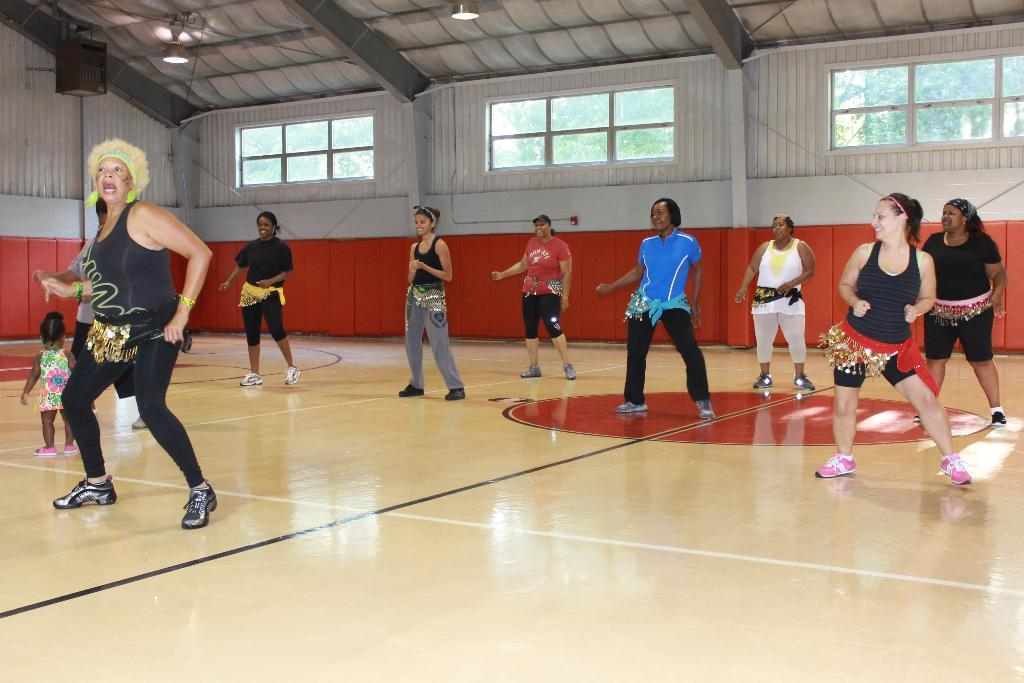How many people are in the image? There is a group of people in the image. Where are the people located in the image? The people are on the floor, near walls, windows, lights, and the roof. What can be seen in the background of the image? There are trees in the background of the image. What else is present in the image besides the people and trees? There are objects in the image. How many bears are visible in the image? There are no bears present in the image. What direction is the wind blowing in the image? There is no indication of wind in the image. 